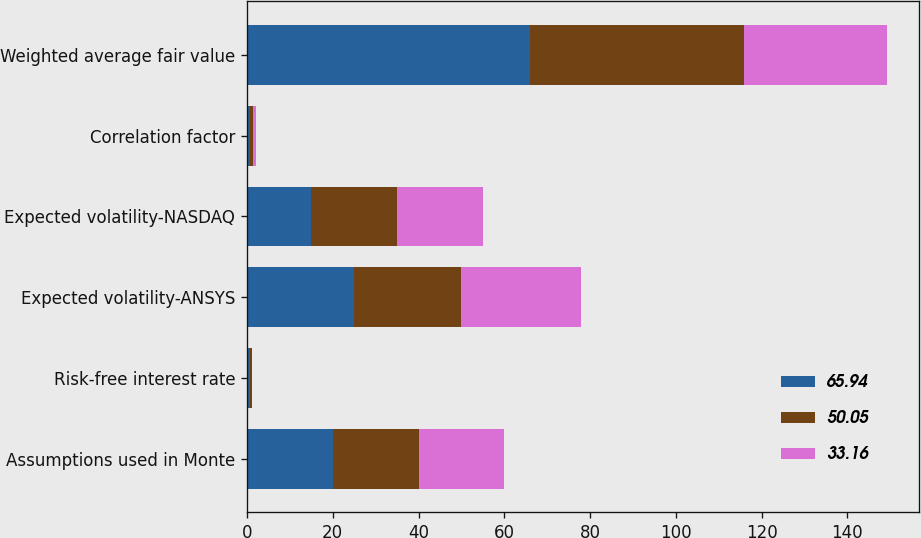Convert chart. <chart><loc_0><loc_0><loc_500><loc_500><stacked_bar_chart><ecel><fcel>Assumptions used in Monte<fcel>Risk-free interest rate<fcel>Expected volatility-ANSYS<fcel>Expected volatility-NASDAQ<fcel>Correlation factor<fcel>Weighted average fair value<nl><fcel>65.94<fcel>20<fcel>0.7<fcel>25<fcel>15<fcel>0.7<fcel>65.94<nl><fcel>50.05<fcel>20<fcel>0.35<fcel>25<fcel>20<fcel>0.7<fcel>50.05<nl><fcel>33.16<fcel>20<fcel>0.16<fcel>28<fcel>20<fcel>0.75<fcel>33.16<nl></chart> 